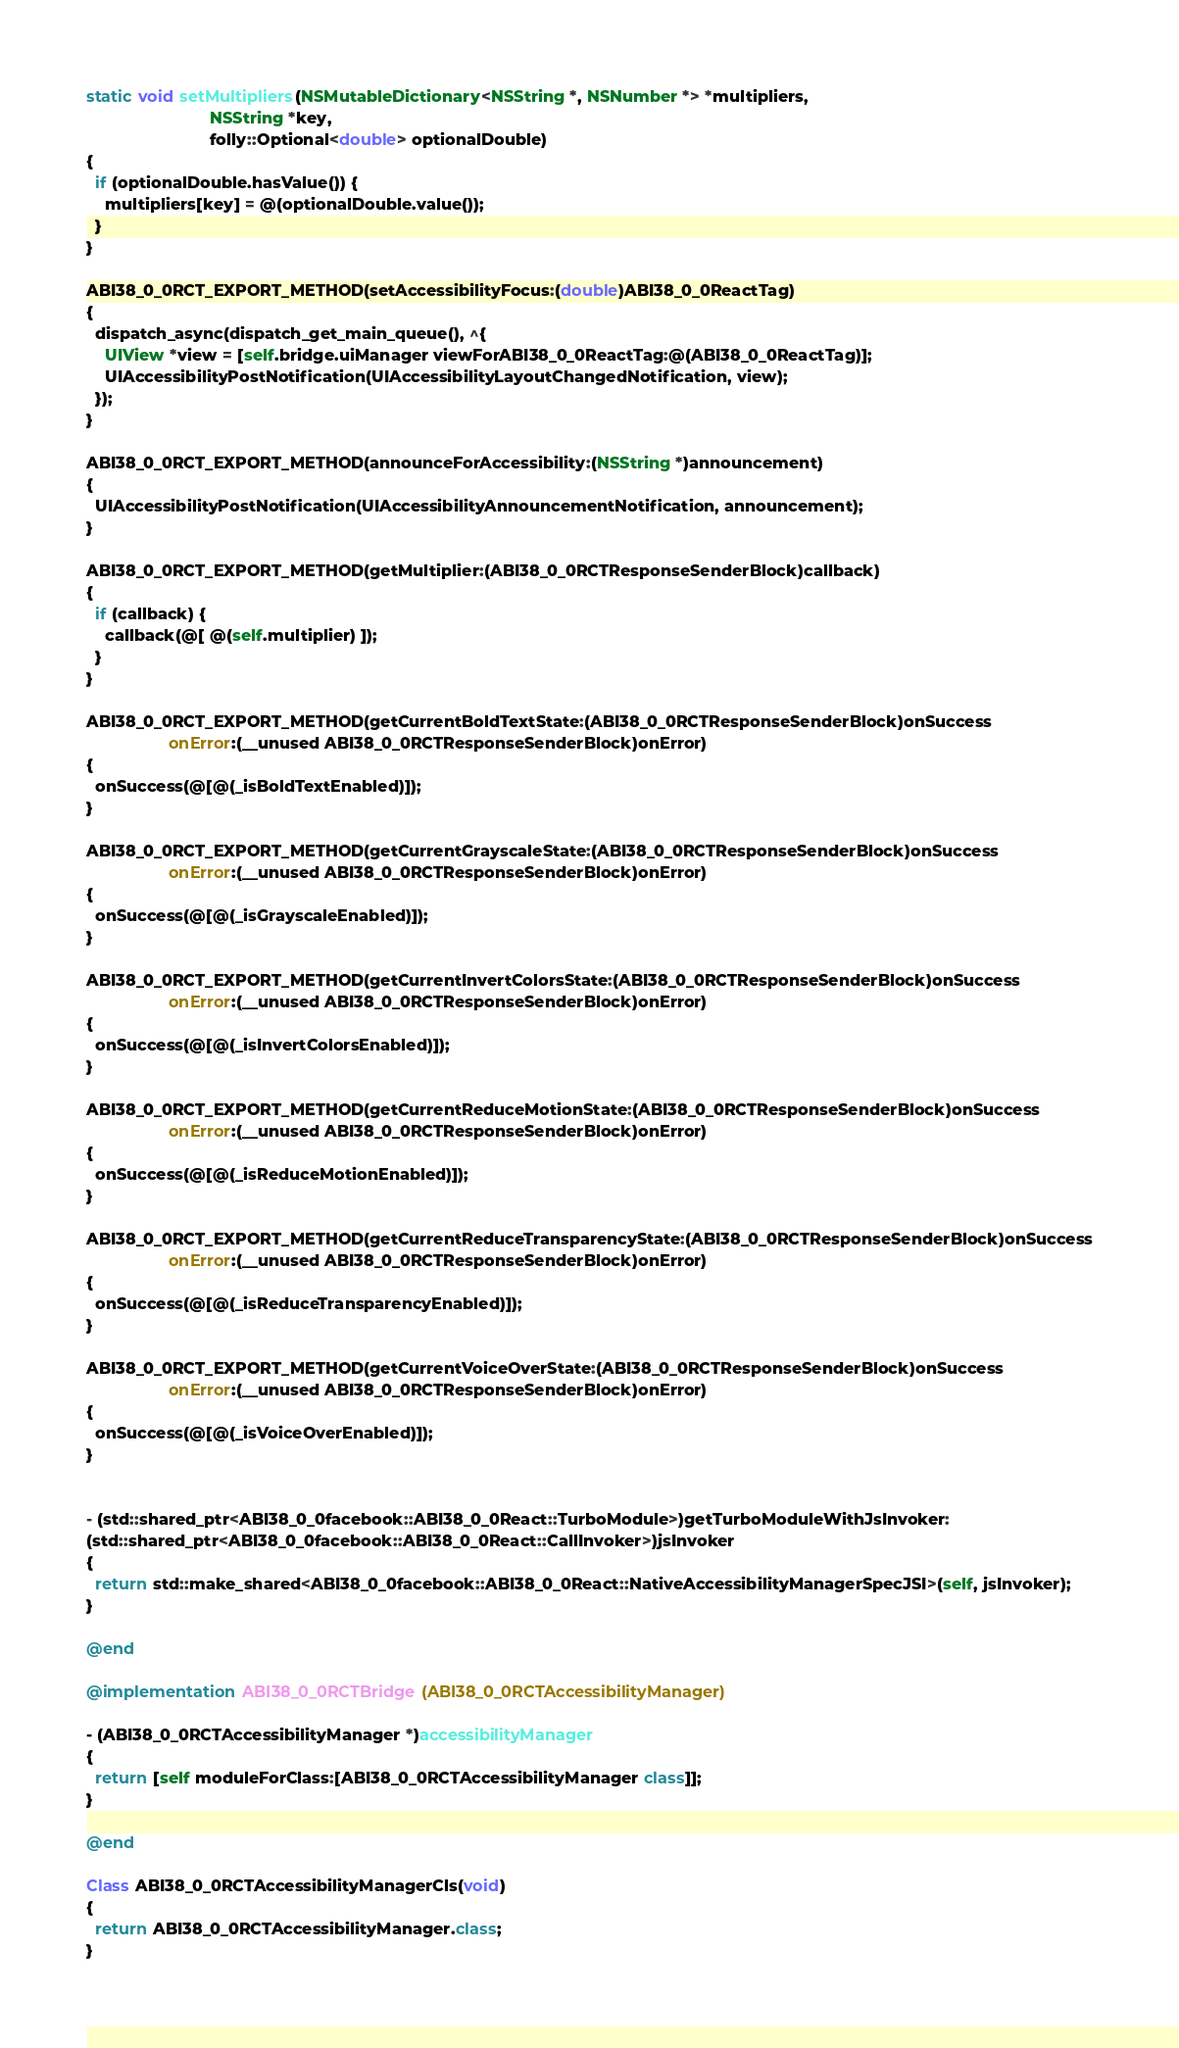<code> <loc_0><loc_0><loc_500><loc_500><_ObjectiveC_>static void setMultipliers(NSMutableDictionary<NSString *, NSNumber *> *multipliers,
                           NSString *key,
                           folly::Optional<double> optionalDouble)
{
  if (optionalDouble.hasValue()) {
    multipliers[key] = @(optionalDouble.value());
  }
}

ABI38_0_0RCT_EXPORT_METHOD(setAccessibilityFocus:(double)ABI38_0_0ReactTag)
{
  dispatch_async(dispatch_get_main_queue(), ^{
    UIView *view = [self.bridge.uiManager viewForABI38_0_0ReactTag:@(ABI38_0_0ReactTag)];
    UIAccessibilityPostNotification(UIAccessibilityLayoutChangedNotification, view);
  });
}

ABI38_0_0RCT_EXPORT_METHOD(announceForAccessibility:(NSString *)announcement)
{
  UIAccessibilityPostNotification(UIAccessibilityAnnouncementNotification, announcement);
}

ABI38_0_0RCT_EXPORT_METHOD(getMultiplier:(ABI38_0_0RCTResponseSenderBlock)callback)
{
  if (callback) {
    callback(@[ @(self.multiplier) ]);
  }
}

ABI38_0_0RCT_EXPORT_METHOD(getCurrentBoldTextState:(ABI38_0_0RCTResponseSenderBlock)onSuccess
                  onError:(__unused ABI38_0_0RCTResponseSenderBlock)onError)
{
  onSuccess(@[@(_isBoldTextEnabled)]);
}

ABI38_0_0RCT_EXPORT_METHOD(getCurrentGrayscaleState:(ABI38_0_0RCTResponseSenderBlock)onSuccess
                  onError:(__unused ABI38_0_0RCTResponseSenderBlock)onError)
{
  onSuccess(@[@(_isGrayscaleEnabled)]);
}

ABI38_0_0RCT_EXPORT_METHOD(getCurrentInvertColorsState:(ABI38_0_0RCTResponseSenderBlock)onSuccess
                  onError:(__unused ABI38_0_0RCTResponseSenderBlock)onError)
{
  onSuccess(@[@(_isInvertColorsEnabled)]);
}

ABI38_0_0RCT_EXPORT_METHOD(getCurrentReduceMotionState:(ABI38_0_0RCTResponseSenderBlock)onSuccess
                  onError:(__unused ABI38_0_0RCTResponseSenderBlock)onError)
{
  onSuccess(@[@(_isReduceMotionEnabled)]);
}

ABI38_0_0RCT_EXPORT_METHOD(getCurrentReduceTransparencyState:(ABI38_0_0RCTResponseSenderBlock)onSuccess
                  onError:(__unused ABI38_0_0RCTResponseSenderBlock)onError)
{
  onSuccess(@[@(_isReduceTransparencyEnabled)]);
}

ABI38_0_0RCT_EXPORT_METHOD(getCurrentVoiceOverState:(ABI38_0_0RCTResponseSenderBlock)onSuccess
                  onError:(__unused ABI38_0_0RCTResponseSenderBlock)onError)
{
  onSuccess(@[@(_isVoiceOverEnabled)]);
}


- (std::shared_ptr<ABI38_0_0facebook::ABI38_0_0React::TurboModule>)getTurboModuleWithJsInvoker:
(std::shared_ptr<ABI38_0_0facebook::ABI38_0_0React::CallInvoker>)jsInvoker
{
  return std::make_shared<ABI38_0_0facebook::ABI38_0_0React::NativeAccessibilityManagerSpecJSI>(self, jsInvoker);
}

@end

@implementation ABI38_0_0RCTBridge (ABI38_0_0RCTAccessibilityManager)

- (ABI38_0_0RCTAccessibilityManager *)accessibilityManager
{
  return [self moduleForClass:[ABI38_0_0RCTAccessibilityManager class]];
}

@end

Class ABI38_0_0RCTAccessibilityManagerCls(void)
{
  return ABI38_0_0RCTAccessibilityManager.class;
}
</code> 